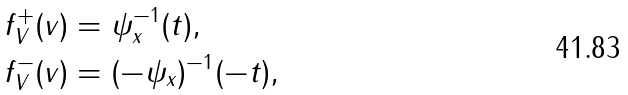<formula> <loc_0><loc_0><loc_500><loc_500>f ^ { + } _ { V } ( v ) & = \psi ^ { - 1 } _ { x } ( t ) , \\ f ^ { - } _ { V } ( v ) & = ( - \psi _ { x } ) ^ { - 1 } ( - t ) ,</formula> 